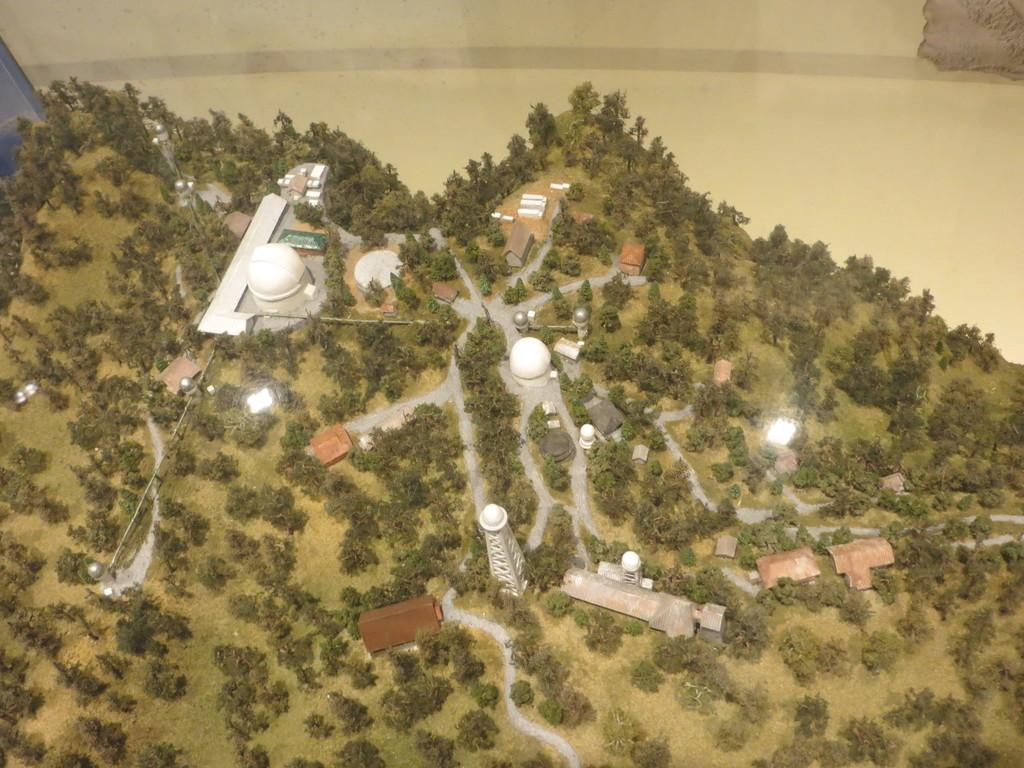What type of vegetation is present in the image? There are trees and grass in the image. What type of structures can be seen in the image? There are towers, houses, and other architectures in the image. Can you see a squirrel playing a drum on one of the trees in the image? There is no squirrel or drum present in the image; it only features trees, grass, towers, houses, and other architectures. 